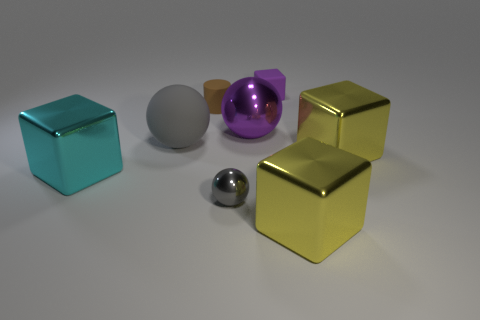Add 1 blue shiny balls. How many objects exist? 9 Subtract all balls. How many objects are left? 5 Subtract 0 brown blocks. How many objects are left? 8 Subtract all large yellow objects. Subtract all brown things. How many objects are left? 5 Add 8 gray metallic things. How many gray metallic things are left? 9 Add 1 purple spheres. How many purple spheres exist? 2 